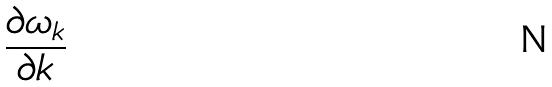<formula> <loc_0><loc_0><loc_500><loc_500>\frac { \partial \omega _ { k } } { \partial k }</formula> 